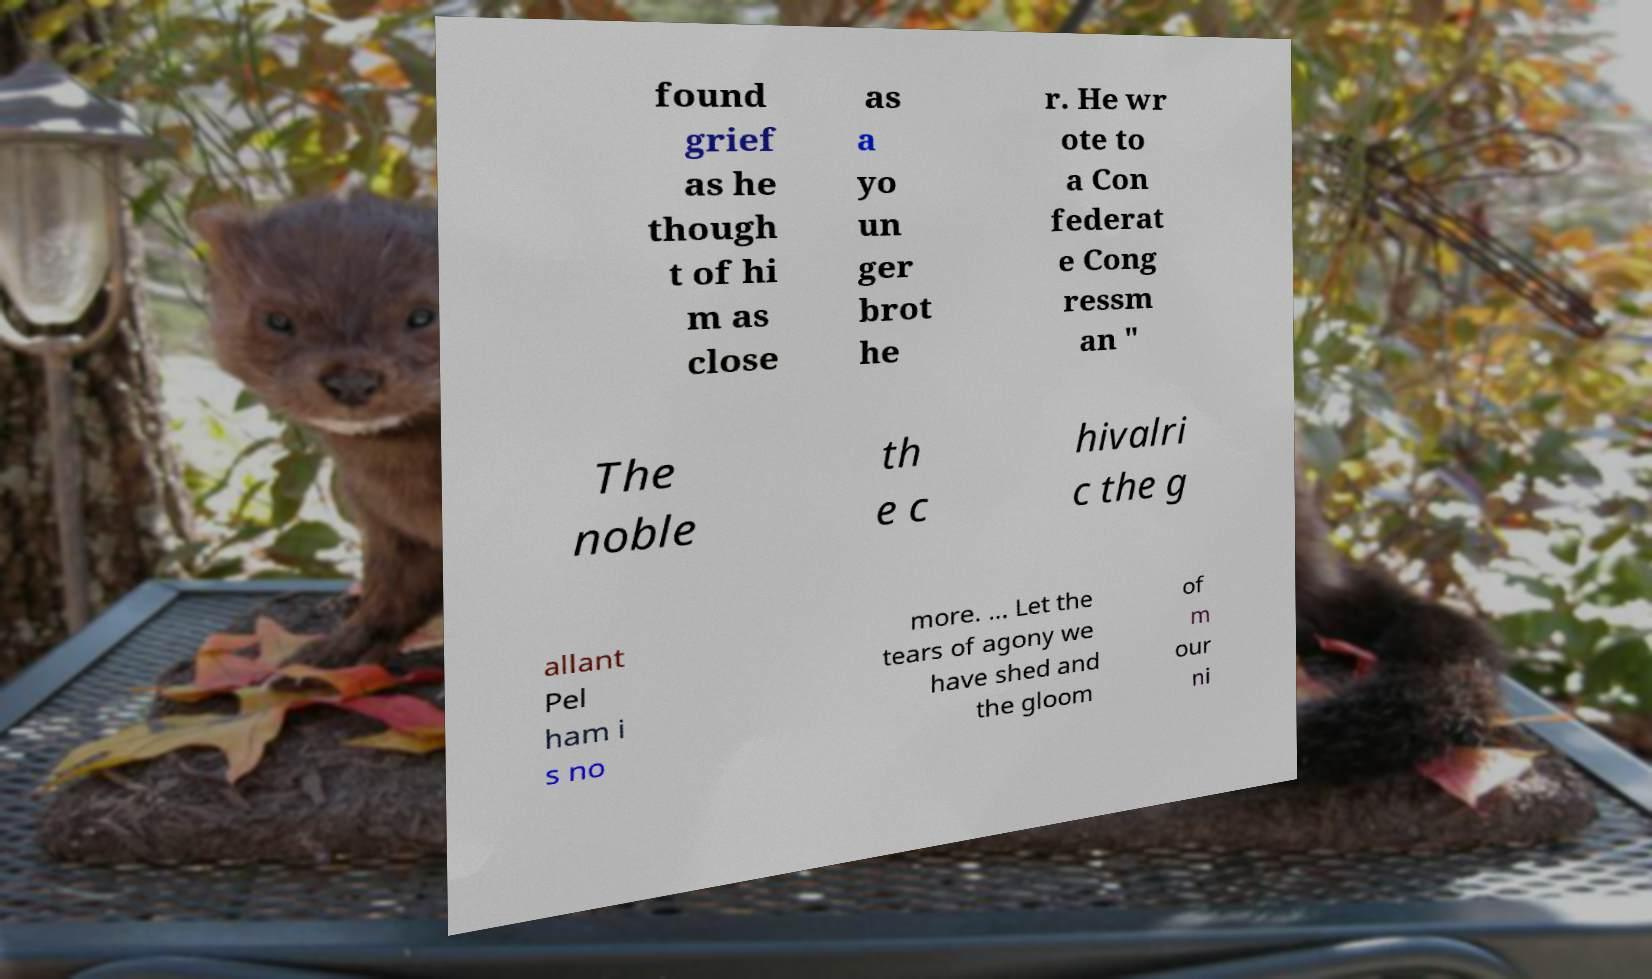Can you read and provide the text displayed in the image?This photo seems to have some interesting text. Can you extract and type it out for me? found grief as he though t of hi m as close as a yo un ger brot he r. He wr ote to a Con federat e Cong ressm an " The noble th e c hivalri c the g allant Pel ham i s no more. ... Let the tears of agony we have shed and the gloom of m our ni 